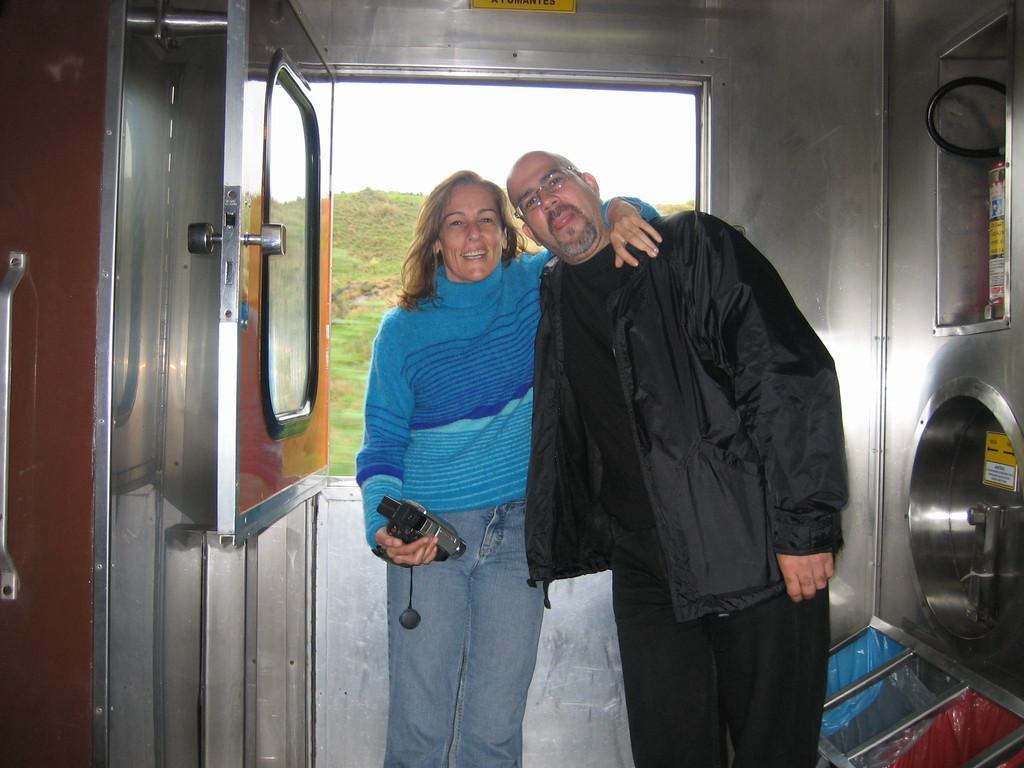Please provide a concise description of this image. In this picture we can see two people, fire extinguisher, door, wall, some objects and a woman holding a camera with her hand and in the background we can see the grass and the sky. 